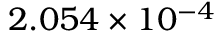<formula> <loc_0><loc_0><loc_500><loc_500>2 . 0 5 4 \times 1 0 ^ { - 4 }</formula> 